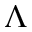<formula> <loc_0><loc_0><loc_500><loc_500>\Lambda</formula> 